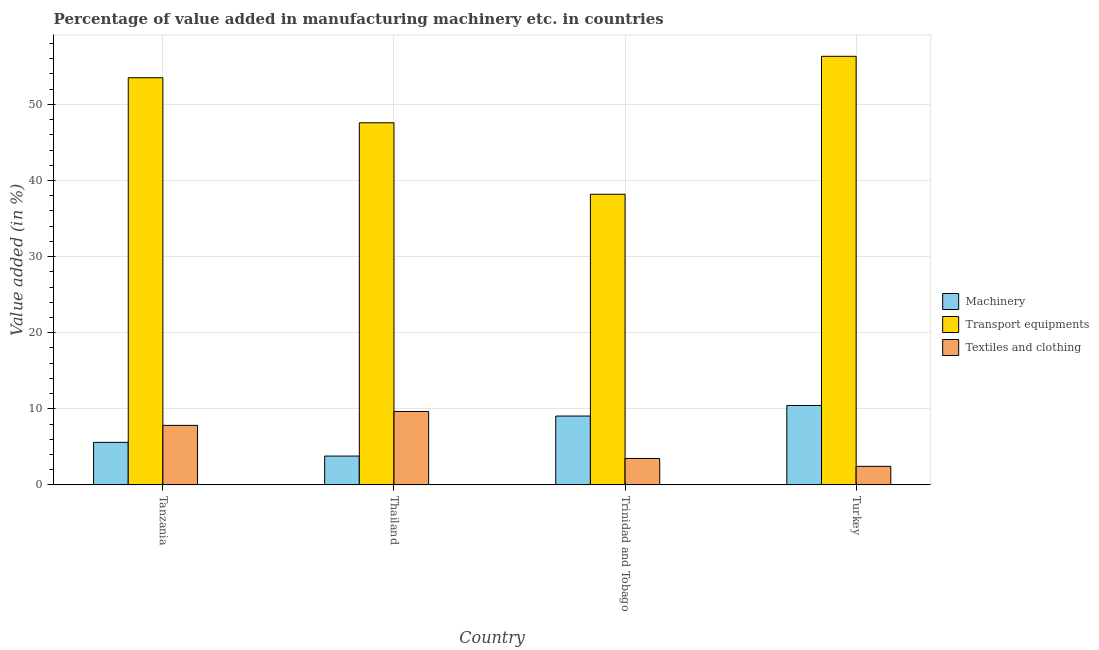How many different coloured bars are there?
Provide a short and direct response. 3. Are the number of bars per tick equal to the number of legend labels?
Your answer should be compact. Yes. Are the number of bars on each tick of the X-axis equal?
Keep it short and to the point. Yes. How many bars are there on the 3rd tick from the right?
Your response must be concise. 3. What is the label of the 2nd group of bars from the left?
Offer a very short reply. Thailand. In how many cases, is the number of bars for a given country not equal to the number of legend labels?
Your response must be concise. 0. What is the value added in manufacturing machinery in Trinidad and Tobago?
Your response must be concise. 9.05. Across all countries, what is the maximum value added in manufacturing machinery?
Provide a succinct answer. 10.44. Across all countries, what is the minimum value added in manufacturing transport equipments?
Offer a very short reply. 38.19. In which country was the value added in manufacturing textile and clothing maximum?
Provide a succinct answer. Thailand. In which country was the value added in manufacturing transport equipments minimum?
Give a very brief answer. Trinidad and Tobago. What is the total value added in manufacturing textile and clothing in the graph?
Your answer should be compact. 23.38. What is the difference between the value added in manufacturing transport equipments in Trinidad and Tobago and that in Turkey?
Provide a succinct answer. -18.13. What is the difference between the value added in manufacturing textile and clothing in Tanzania and the value added in manufacturing machinery in Trinidad and Tobago?
Your response must be concise. -1.22. What is the average value added in manufacturing textile and clothing per country?
Offer a very short reply. 5.84. What is the difference between the value added in manufacturing textile and clothing and value added in manufacturing machinery in Trinidad and Tobago?
Offer a terse response. -5.57. What is the ratio of the value added in manufacturing textile and clothing in Tanzania to that in Trinidad and Tobago?
Provide a succinct answer. 2.25. Is the value added in manufacturing textile and clothing in Tanzania less than that in Turkey?
Your answer should be very brief. No. What is the difference between the highest and the second highest value added in manufacturing transport equipments?
Provide a short and direct response. 2.82. What is the difference between the highest and the lowest value added in manufacturing transport equipments?
Provide a short and direct response. 18.13. What does the 1st bar from the left in Thailand represents?
Your response must be concise. Machinery. What does the 3rd bar from the right in Thailand represents?
Give a very brief answer. Machinery. Is it the case that in every country, the sum of the value added in manufacturing machinery and value added in manufacturing transport equipments is greater than the value added in manufacturing textile and clothing?
Keep it short and to the point. Yes. How many bars are there?
Provide a short and direct response. 12. What is the title of the graph?
Keep it short and to the point. Percentage of value added in manufacturing machinery etc. in countries. What is the label or title of the X-axis?
Ensure brevity in your answer.  Country. What is the label or title of the Y-axis?
Your answer should be very brief. Value added (in %). What is the Value added (in %) in Machinery in Tanzania?
Make the answer very short. 5.59. What is the Value added (in %) in Transport equipments in Tanzania?
Your answer should be very brief. 53.5. What is the Value added (in %) of Textiles and clothing in Tanzania?
Make the answer very short. 7.82. What is the Value added (in %) of Machinery in Thailand?
Keep it short and to the point. 3.79. What is the Value added (in %) of Transport equipments in Thailand?
Offer a very short reply. 47.59. What is the Value added (in %) in Textiles and clothing in Thailand?
Ensure brevity in your answer.  9.65. What is the Value added (in %) in Machinery in Trinidad and Tobago?
Make the answer very short. 9.05. What is the Value added (in %) of Transport equipments in Trinidad and Tobago?
Your answer should be very brief. 38.19. What is the Value added (in %) of Textiles and clothing in Trinidad and Tobago?
Offer a very short reply. 3.47. What is the Value added (in %) of Machinery in Turkey?
Make the answer very short. 10.44. What is the Value added (in %) of Transport equipments in Turkey?
Provide a succinct answer. 56.32. What is the Value added (in %) of Textiles and clothing in Turkey?
Offer a terse response. 2.44. Across all countries, what is the maximum Value added (in %) of Machinery?
Give a very brief answer. 10.44. Across all countries, what is the maximum Value added (in %) in Transport equipments?
Offer a very short reply. 56.32. Across all countries, what is the maximum Value added (in %) in Textiles and clothing?
Your answer should be compact. 9.65. Across all countries, what is the minimum Value added (in %) of Machinery?
Provide a succinct answer. 3.79. Across all countries, what is the minimum Value added (in %) of Transport equipments?
Provide a short and direct response. 38.19. Across all countries, what is the minimum Value added (in %) of Textiles and clothing?
Keep it short and to the point. 2.44. What is the total Value added (in %) of Machinery in the graph?
Your answer should be very brief. 28.86. What is the total Value added (in %) in Transport equipments in the graph?
Provide a succinct answer. 195.6. What is the total Value added (in %) in Textiles and clothing in the graph?
Ensure brevity in your answer.  23.38. What is the difference between the Value added (in %) in Machinery in Tanzania and that in Thailand?
Provide a short and direct response. 1.8. What is the difference between the Value added (in %) of Transport equipments in Tanzania and that in Thailand?
Provide a succinct answer. 5.92. What is the difference between the Value added (in %) in Textiles and clothing in Tanzania and that in Thailand?
Offer a very short reply. -1.83. What is the difference between the Value added (in %) in Machinery in Tanzania and that in Trinidad and Tobago?
Your answer should be compact. -3.45. What is the difference between the Value added (in %) of Transport equipments in Tanzania and that in Trinidad and Tobago?
Make the answer very short. 15.31. What is the difference between the Value added (in %) of Textiles and clothing in Tanzania and that in Trinidad and Tobago?
Give a very brief answer. 4.35. What is the difference between the Value added (in %) of Machinery in Tanzania and that in Turkey?
Give a very brief answer. -4.85. What is the difference between the Value added (in %) of Transport equipments in Tanzania and that in Turkey?
Ensure brevity in your answer.  -2.82. What is the difference between the Value added (in %) of Textiles and clothing in Tanzania and that in Turkey?
Your response must be concise. 5.38. What is the difference between the Value added (in %) of Machinery in Thailand and that in Trinidad and Tobago?
Ensure brevity in your answer.  -5.26. What is the difference between the Value added (in %) of Transport equipments in Thailand and that in Trinidad and Tobago?
Make the answer very short. 9.4. What is the difference between the Value added (in %) of Textiles and clothing in Thailand and that in Trinidad and Tobago?
Your answer should be very brief. 6.18. What is the difference between the Value added (in %) of Machinery in Thailand and that in Turkey?
Make the answer very short. -6.65. What is the difference between the Value added (in %) of Transport equipments in Thailand and that in Turkey?
Give a very brief answer. -8.73. What is the difference between the Value added (in %) of Textiles and clothing in Thailand and that in Turkey?
Provide a succinct answer. 7.21. What is the difference between the Value added (in %) in Machinery in Trinidad and Tobago and that in Turkey?
Make the answer very short. -1.39. What is the difference between the Value added (in %) in Transport equipments in Trinidad and Tobago and that in Turkey?
Your answer should be compact. -18.13. What is the difference between the Value added (in %) in Textiles and clothing in Trinidad and Tobago and that in Turkey?
Offer a terse response. 1.03. What is the difference between the Value added (in %) in Machinery in Tanzania and the Value added (in %) in Transport equipments in Thailand?
Offer a terse response. -42. What is the difference between the Value added (in %) of Machinery in Tanzania and the Value added (in %) of Textiles and clothing in Thailand?
Keep it short and to the point. -4.06. What is the difference between the Value added (in %) in Transport equipments in Tanzania and the Value added (in %) in Textiles and clothing in Thailand?
Your answer should be compact. 43.86. What is the difference between the Value added (in %) in Machinery in Tanzania and the Value added (in %) in Transport equipments in Trinidad and Tobago?
Offer a very short reply. -32.6. What is the difference between the Value added (in %) in Machinery in Tanzania and the Value added (in %) in Textiles and clothing in Trinidad and Tobago?
Make the answer very short. 2.12. What is the difference between the Value added (in %) in Transport equipments in Tanzania and the Value added (in %) in Textiles and clothing in Trinidad and Tobago?
Keep it short and to the point. 50.03. What is the difference between the Value added (in %) in Machinery in Tanzania and the Value added (in %) in Transport equipments in Turkey?
Your answer should be very brief. -50.73. What is the difference between the Value added (in %) of Machinery in Tanzania and the Value added (in %) of Textiles and clothing in Turkey?
Your answer should be compact. 3.15. What is the difference between the Value added (in %) of Transport equipments in Tanzania and the Value added (in %) of Textiles and clothing in Turkey?
Ensure brevity in your answer.  51.06. What is the difference between the Value added (in %) of Machinery in Thailand and the Value added (in %) of Transport equipments in Trinidad and Tobago?
Offer a very short reply. -34.4. What is the difference between the Value added (in %) of Machinery in Thailand and the Value added (in %) of Textiles and clothing in Trinidad and Tobago?
Your answer should be compact. 0.32. What is the difference between the Value added (in %) in Transport equipments in Thailand and the Value added (in %) in Textiles and clothing in Trinidad and Tobago?
Make the answer very short. 44.12. What is the difference between the Value added (in %) in Machinery in Thailand and the Value added (in %) in Transport equipments in Turkey?
Ensure brevity in your answer.  -52.53. What is the difference between the Value added (in %) in Machinery in Thailand and the Value added (in %) in Textiles and clothing in Turkey?
Give a very brief answer. 1.35. What is the difference between the Value added (in %) of Transport equipments in Thailand and the Value added (in %) of Textiles and clothing in Turkey?
Ensure brevity in your answer.  45.15. What is the difference between the Value added (in %) in Machinery in Trinidad and Tobago and the Value added (in %) in Transport equipments in Turkey?
Make the answer very short. -47.27. What is the difference between the Value added (in %) in Machinery in Trinidad and Tobago and the Value added (in %) in Textiles and clothing in Turkey?
Make the answer very short. 6.61. What is the difference between the Value added (in %) in Transport equipments in Trinidad and Tobago and the Value added (in %) in Textiles and clothing in Turkey?
Offer a terse response. 35.75. What is the average Value added (in %) in Machinery per country?
Your answer should be very brief. 7.22. What is the average Value added (in %) of Transport equipments per country?
Give a very brief answer. 48.9. What is the average Value added (in %) of Textiles and clothing per country?
Your answer should be compact. 5.84. What is the difference between the Value added (in %) in Machinery and Value added (in %) in Transport equipments in Tanzania?
Provide a short and direct response. -47.91. What is the difference between the Value added (in %) of Machinery and Value added (in %) of Textiles and clothing in Tanzania?
Keep it short and to the point. -2.23. What is the difference between the Value added (in %) of Transport equipments and Value added (in %) of Textiles and clothing in Tanzania?
Your answer should be very brief. 45.68. What is the difference between the Value added (in %) of Machinery and Value added (in %) of Transport equipments in Thailand?
Offer a very short reply. -43.8. What is the difference between the Value added (in %) in Machinery and Value added (in %) in Textiles and clothing in Thailand?
Your answer should be compact. -5.86. What is the difference between the Value added (in %) in Transport equipments and Value added (in %) in Textiles and clothing in Thailand?
Give a very brief answer. 37.94. What is the difference between the Value added (in %) of Machinery and Value added (in %) of Transport equipments in Trinidad and Tobago?
Make the answer very short. -29.15. What is the difference between the Value added (in %) of Machinery and Value added (in %) of Textiles and clothing in Trinidad and Tobago?
Give a very brief answer. 5.57. What is the difference between the Value added (in %) in Transport equipments and Value added (in %) in Textiles and clothing in Trinidad and Tobago?
Provide a short and direct response. 34.72. What is the difference between the Value added (in %) of Machinery and Value added (in %) of Transport equipments in Turkey?
Make the answer very short. -45.88. What is the difference between the Value added (in %) in Machinery and Value added (in %) in Textiles and clothing in Turkey?
Provide a succinct answer. 8. What is the difference between the Value added (in %) of Transport equipments and Value added (in %) of Textiles and clothing in Turkey?
Your response must be concise. 53.88. What is the ratio of the Value added (in %) of Machinery in Tanzania to that in Thailand?
Your answer should be very brief. 1.48. What is the ratio of the Value added (in %) in Transport equipments in Tanzania to that in Thailand?
Your answer should be very brief. 1.12. What is the ratio of the Value added (in %) of Textiles and clothing in Tanzania to that in Thailand?
Give a very brief answer. 0.81. What is the ratio of the Value added (in %) of Machinery in Tanzania to that in Trinidad and Tobago?
Offer a terse response. 0.62. What is the ratio of the Value added (in %) of Transport equipments in Tanzania to that in Trinidad and Tobago?
Your answer should be compact. 1.4. What is the ratio of the Value added (in %) of Textiles and clothing in Tanzania to that in Trinidad and Tobago?
Offer a terse response. 2.25. What is the ratio of the Value added (in %) of Machinery in Tanzania to that in Turkey?
Your response must be concise. 0.54. What is the ratio of the Value added (in %) in Transport equipments in Tanzania to that in Turkey?
Your answer should be compact. 0.95. What is the ratio of the Value added (in %) of Textiles and clothing in Tanzania to that in Turkey?
Your answer should be very brief. 3.21. What is the ratio of the Value added (in %) in Machinery in Thailand to that in Trinidad and Tobago?
Offer a terse response. 0.42. What is the ratio of the Value added (in %) of Transport equipments in Thailand to that in Trinidad and Tobago?
Make the answer very short. 1.25. What is the ratio of the Value added (in %) of Textiles and clothing in Thailand to that in Trinidad and Tobago?
Make the answer very short. 2.78. What is the ratio of the Value added (in %) of Machinery in Thailand to that in Turkey?
Make the answer very short. 0.36. What is the ratio of the Value added (in %) in Transport equipments in Thailand to that in Turkey?
Your answer should be very brief. 0.84. What is the ratio of the Value added (in %) of Textiles and clothing in Thailand to that in Turkey?
Provide a short and direct response. 3.96. What is the ratio of the Value added (in %) in Machinery in Trinidad and Tobago to that in Turkey?
Your answer should be compact. 0.87. What is the ratio of the Value added (in %) of Transport equipments in Trinidad and Tobago to that in Turkey?
Provide a short and direct response. 0.68. What is the ratio of the Value added (in %) in Textiles and clothing in Trinidad and Tobago to that in Turkey?
Provide a succinct answer. 1.42. What is the difference between the highest and the second highest Value added (in %) in Machinery?
Provide a succinct answer. 1.39. What is the difference between the highest and the second highest Value added (in %) in Transport equipments?
Offer a very short reply. 2.82. What is the difference between the highest and the second highest Value added (in %) of Textiles and clothing?
Make the answer very short. 1.83. What is the difference between the highest and the lowest Value added (in %) of Machinery?
Offer a terse response. 6.65. What is the difference between the highest and the lowest Value added (in %) in Transport equipments?
Keep it short and to the point. 18.13. What is the difference between the highest and the lowest Value added (in %) in Textiles and clothing?
Provide a succinct answer. 7.21. 